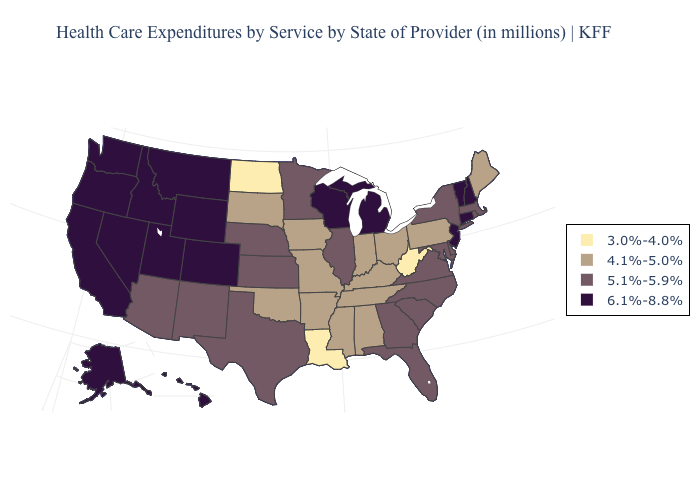What is the lowest value in the USA?
Be succinct. 3.0%-4.0%. What is the value of Connecticut?
Quick response, please. 6.1%-8.8%. Name the states that have a value in the range 5.1%-5.9%?
Answer briefly. Arizona, Delaware, Florida, Georgia, Illinois, Kansas, Maryland, Massachusetts, Minnesota, Nebraska, New Mexico, New York, North Carolina, Rhode Island, South Carolina, Texas, Virginia. Among the states that border Louisiana , does Arkansas have the highest value?
Write a very short answer. No. Among the states that border Colorado , does Oklahoma have the lowest value?
Keep it brief. Yes. What is the highest value in states that border Nebraska?
Short answer required. 6.1%-8.8%. What is the lowest value in states that border Rhode Island?
Keep it brief. 5.1%-5.9%. Does Wisconsin have the highest value in the USA?
Short answer required. Yes. Among the states that border Rhode Island , does Connecticut have the lowest value?
Be succinct. No. Which states have the highest value in the USA?
Concise answer only. Alaska, California, Colorado, Connecticut, Hawaii, Idaho, Michigan, Montana, Nevada, New Hampshire, New Jersey, Oregon, Utah, Vermont, Washington, Wisconsin, Wyoming. Does the map have missing data?
Give a very brief answer. No. What is the value of Wyoming?
Answer briefly. 6.1%-8.8%. What is the value of Minnesota?
Concise answer only. 5.1%-5.9%. Name the states that have a value in the range 4.1%-5.0%?
Quick response, please. Alabama, Arkansas, Indiana, Iowa, Kentucky, Maine, Mississippi, Missouri, Ohio, Oklahoma, Pennsylvania, South Dakota, Tennessee. Which states hav the highest value in the Northeast?
Answer briefly. Connecticut, New Hampshire, New Jersey, Vermont. 